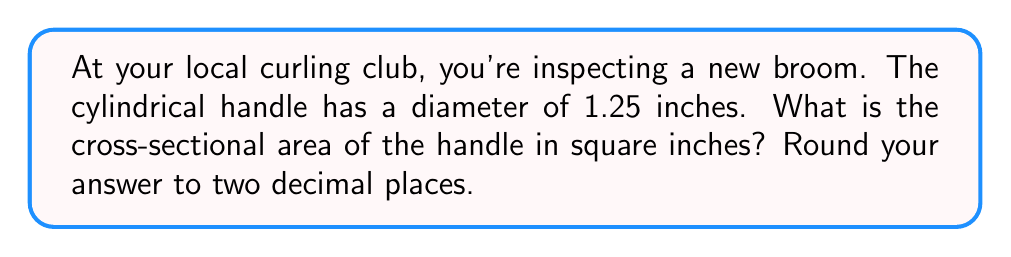Show me your answer to this math problem. Let's approach this step-by-step:

1) The cross-section of a cylindrical handle is a circle.

2) To find the area of a circle, we use the formula:

   $$A = \pi r^2$$

   Where $A$ is the area and $r$ is the radius.

3) We're given the diameter, which is 1.25 inches. To get the radius, we divide the diameter by 2:

   $$r = \frac{1.25}{2} = 0.625\text{ inches}$$

4) Now we can plug this into our area formula:

   $$A = \pi (0.625)^2$$

5) Let's calculate:

   $$A = \pi * 0.390625 \approx 1.2271\text{ square inches}$$

6) Rounding to two decimal places:

   $$A \approx 1.23\text{ square inches}$$
Answer: $1.23\text{ in}^2$ 